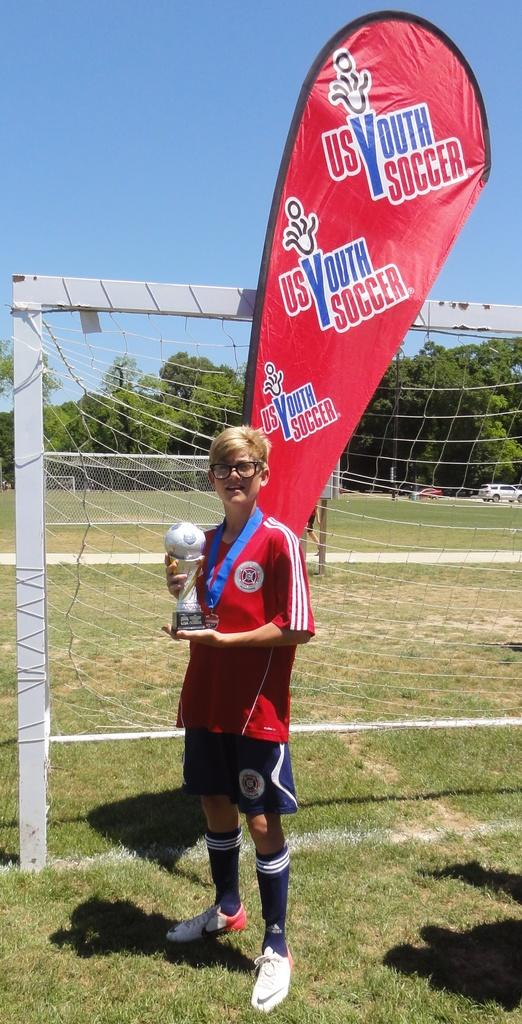<image>
Provide a brief description of the given image. the words youth soccer are on the red item 